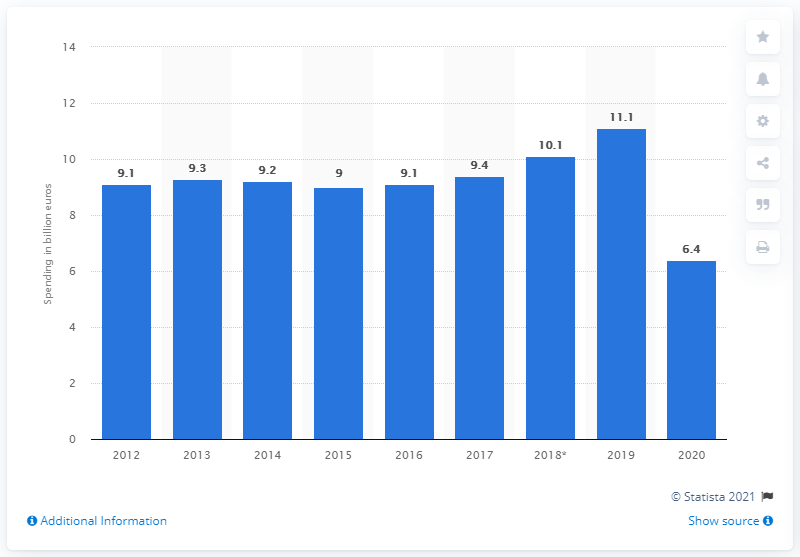Outline some significant characteristics in this image. In 2020, Greece's tourism spending was approximately 6.4 billion dollars. In 2019, Greece's tourism spending reached its peak at 11.1 billion US dollars. 